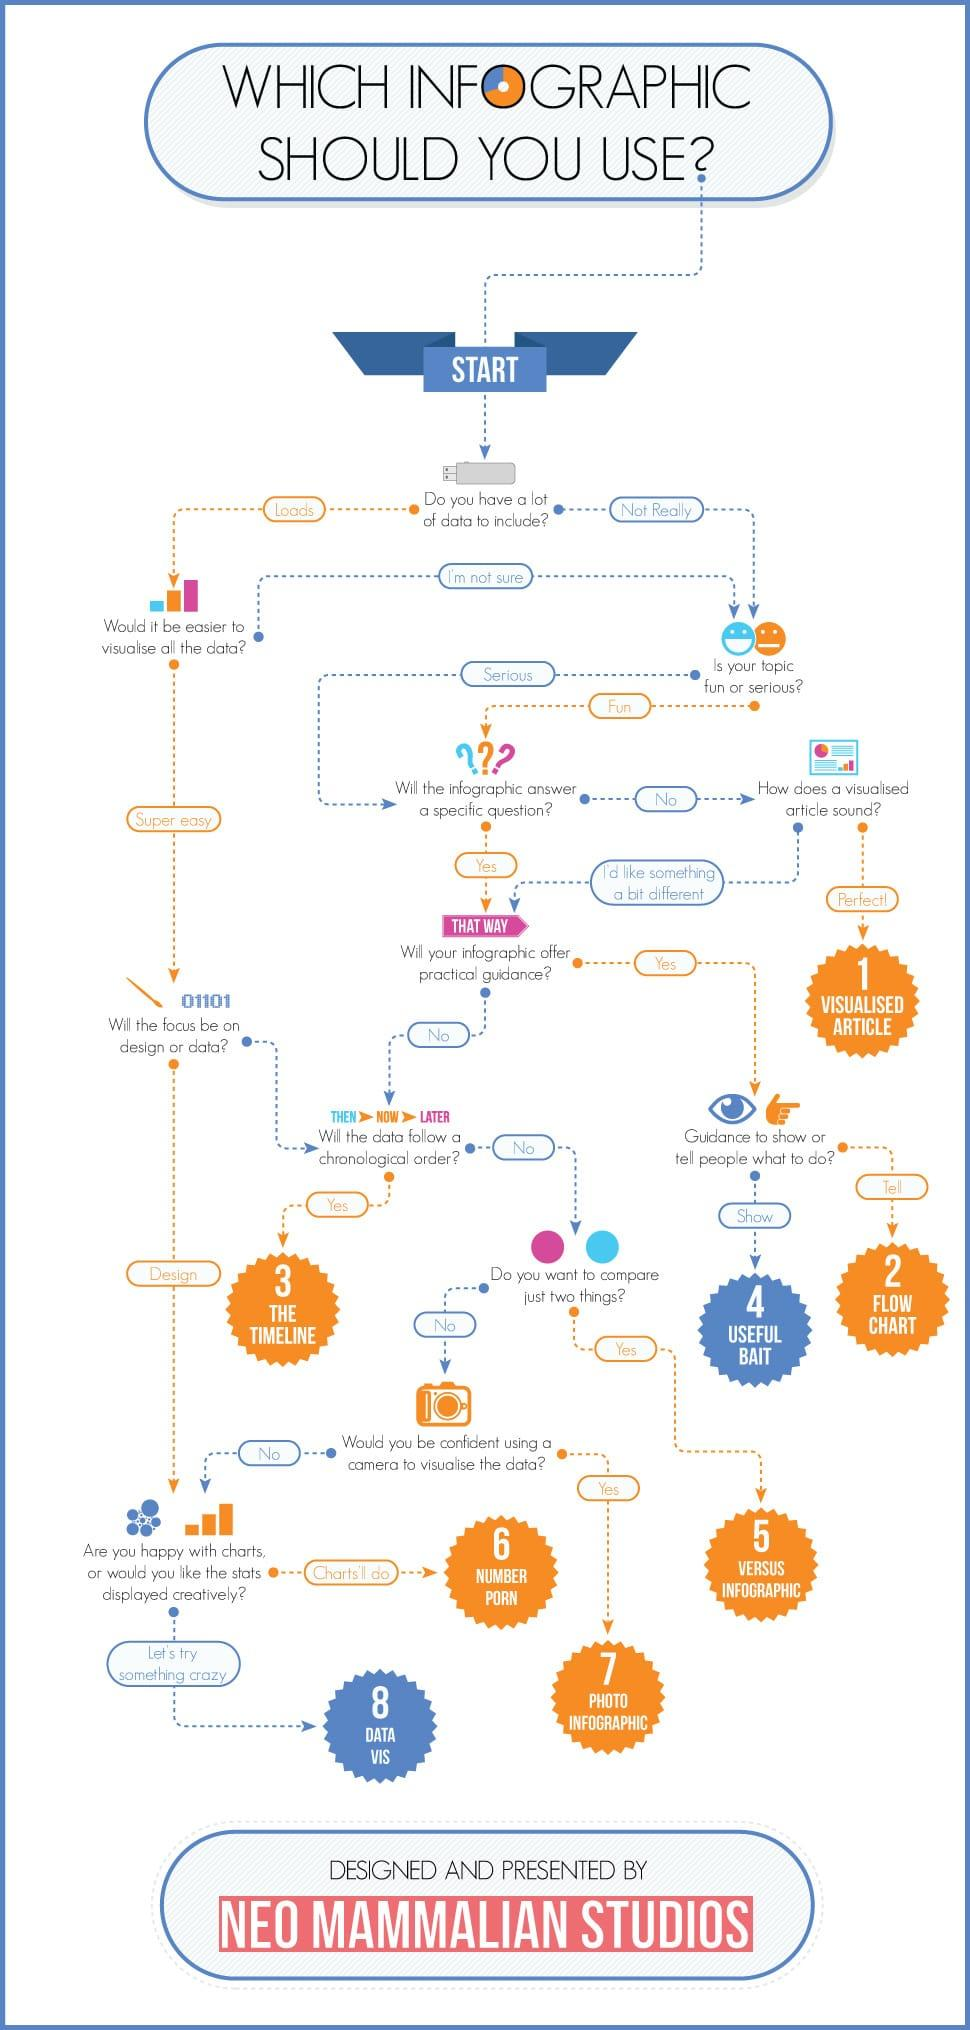List a handful of essential elements in this visual. If an infographic is not the preferred solution, a visualized article can be used instead. The data should be represented in a timeline if it has chronology, flow chart, timeline, or photo infographic. It is recommended that data intended to instruct people be represented in the form of a flow chart. 